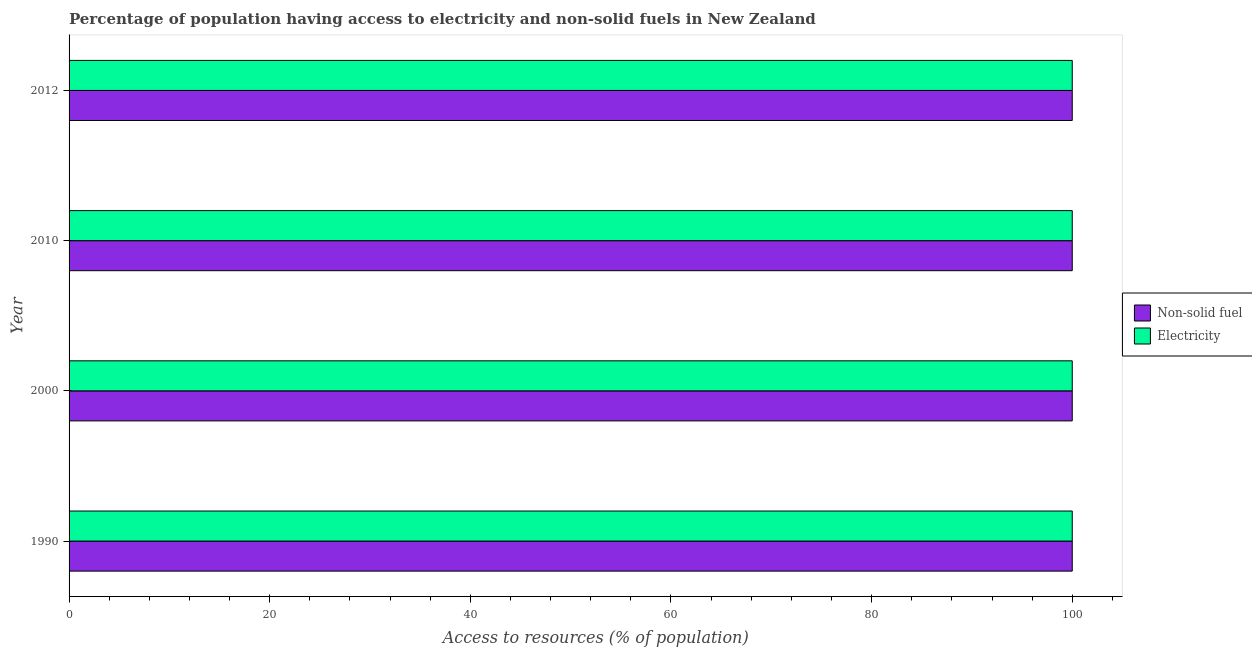How many groups of bars are there?
Your answer should be compact. 4. Are the number of bars per tick equal to the number of legend labels?
Ensure brevity in your answer.  Yes. Are the number of bars on each tick of the Y-axis equal?
Provide a succinct answer. Yes. How many bars are there on the 4th tick from the top?
Offer a very short reply. 2. How many bars are there on the 4th tick from the bottom?
Ensure brevity in your answer.  2. What is the label of the 3rd group of bars from the top?
Provide a succinct answer. 2000. What is the percentage of population having access to electricity in 1990?
Provide a succinct answer. 100. Across all years, what is the maximum percentage of population having access to non-solid fuel?
Give a very brief answer. 100. Across all years, what is the minimum percentage of population having access to non-solid fuel?
Offer a very short reply. 100. In which year was the percentage of population having access to non-solid fuel maximum?
Your answer should be very brief. 1990. In which year was the percentage of population having access to non-solid fuel minimum?
Offer a terse response. 1990. What is the total percentage of population having access to electricity in the graph?
Provide a short and direct response. 400. In the year 1990, what is the difference between the percentage of population having access to non-solid fuel and percentage of population having access to electricity?
Offer a very short reply. 0. In how many years, is the percentage of population having access to electricity greater than 88 %?
Provide a short and direct response. 4. What does the 2nd bar from the top in 2010 represents?
Provide a short and direct response. Non-solid fuel. What does the 2nd bar from the bottom in 1990 represents?
Keep it short and to the point. Electricity. Are all the bars in the graph horizontal?
Give a very brief answer. Yes. How many legend labels are there?
Make the answer very short. 2. How are the legend labels stacked?
Keep it short and to the point. Vertical. What is the title of the graph?
Your answer should be compact. Percentage of population having access to electricity and non-solid fuels in New Zealand. Does "Birth rate" appear as one of the legend labels in the graph?
Ensure brevity in your answer.  No. What is the label or title of the X-axis?
Give a very brief answer. Access to resources (% of population). What is the Access to resources (% of population) of Electricity in 2010?
Keep it short and to the point. 100. What is the Access to resources (% of population) of Non-solid fuel in 2012?
Offer a terse response. 100. Across all years, what is the maximum Access to resources (% of population) in Electricity?
Provide a succinct answer. 100. What is the total Access to resources (% of population) in Non-solid fuel in the graph?
Make the answer very short. 400. What is the difference between the Access to resources (% of population) of Electricity in 1990 and that in 2000?
Ensure brevity in your answer.  0. What is the difference between the Access to resources (% of population) in Electricity in 1990 and that in 2010?
Your response must be concise. 0. What is the difference between the Access to resources (% of population) in Electricity in 1990 and that in 2012?
Ensure brevity in your answer.  0. What is the difference between the Access to resources (% of population) of Non-solid fuel in 2000 and that in 2010?
Make the answer very short. 0. What is the difference between the Access to resources (% of population) in Electricity in 2000 and that in 2010?
Your response must be concise. 0. What is the difference between the Access to resources (% of population) of Non-solid fuel in 2000 and that in 2012?
Offer a very short reply. 0. What is the difference between the Access to resources (% of population) of Electricity in 2000 and that in 2012?
Ensure brevity in your answer.  0. What is the difference between the Access to resources (% of population) in Electricity in 2010 and that in 2012?
Keep it short and to the point. 0. What is the difference between the Access to resources (% of population) of Non-solid fuel in 2000 and the Access to resources (% of population) of Electricity in 2010?
Your answer should be compact. 0. What is the difference between the Access to resources (% of population) of Non-solid fuel in 2000 and the Access to resources (% of population) of Electricity in 2012?
Your response must be concise. 0. What is the average Access to resources (% of population) of Non-solid fuel per year?
Offer a very short reply. 100. What is the average Access to resources (% of population) in Electricity per year?
Your answer should be compact. 100. In the year 2000, what is the difference between the Access to resources (% of population) in Non-solid fuel and Access to resources (% of population) in Electricity?
Your response must be concise. 0. What is the ratio of the Access to resources (% of population) of Non-solid fuel in 1990 to that in 2000?
Ensure brevity in your answer.  1. What is the ratio of the Access to resources (% of population) in Electricity in 1990 to that in 2010?
Provide a short and direct response. 1. What is the ratio of the Access to resources (% of population) of Electricity in 1990 to that in 2012?
Offer a very short reply. 1. What is the ratio of the Access to resources (% of population) of Electricity in 2000 to that in 2012?
Make the answer very short. 1. What is the ratio of the Access to resources (% of population) in Non-solid fuel in 2010 to that in 2012?
Ensure brevity in your answer.  1. What is the difference between the highest and the lowest Access to resources (% of population) of Non-solid fuel?
Keep it short and to the point. 0. What is the difference between the highest and the lowest Access to resources (% of population) in Electricity?
Provide a succinct answer. 0. 